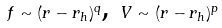<formula> <loc_0><loc_0><loc_500><loc_500>f \sim ( r - r _ { h } ) ^ { q } \text {, } V \sim ( r - r _ { h } ) ^ { p }</formula> 